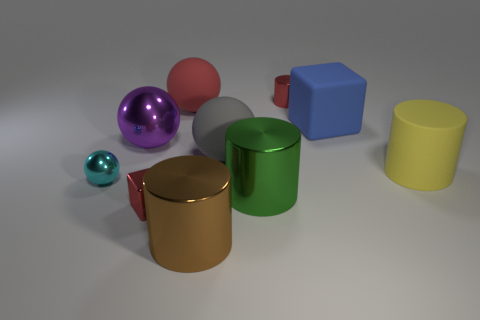Subtract all gray matte spheres. How many spheres are left? 3 Subtract 1 cylinders. How many cylinders are left? 3 Subtract all brown cylinders. How many cylinders are left? 3 Subtract all purple balls. Subtract all cyan cubes. How many balls are left? 3 Subtract all small cylinders. Subtract all gray blocks. How many objects are left? 9 Add 7 tiny metal balls. How many tiny metal balls are left? 8 Add 7 big blue rubber cubes. How many big blue rubber cubes exist? 8 Subtract 0 yellow balls. How many objects are left? 10 Subtract all cylinders. How many objects are left? 6 